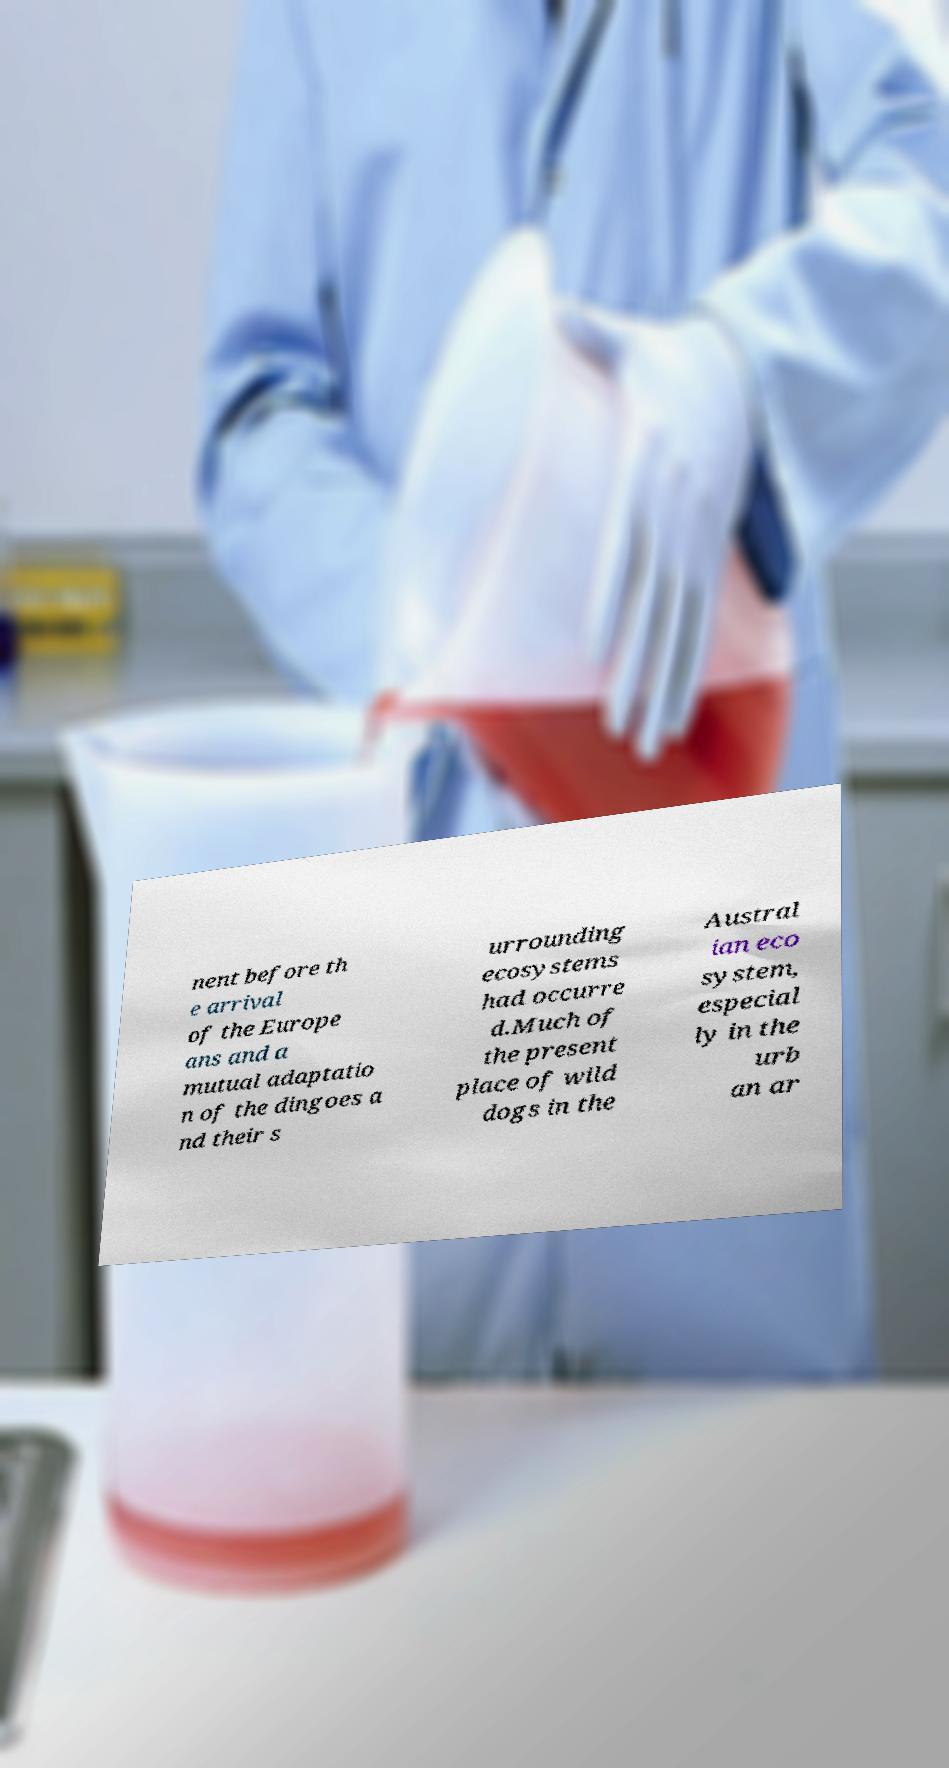Please identify and transcribe the text found in this image. nent before th e arrival of the Europe ans and a mutual adaptatio n of the dingoes a nd their s urrounding ecosystems had occurre d.Much of the present place of wild dogs in the Austral ian eco system, especial ly in the urb an ar 